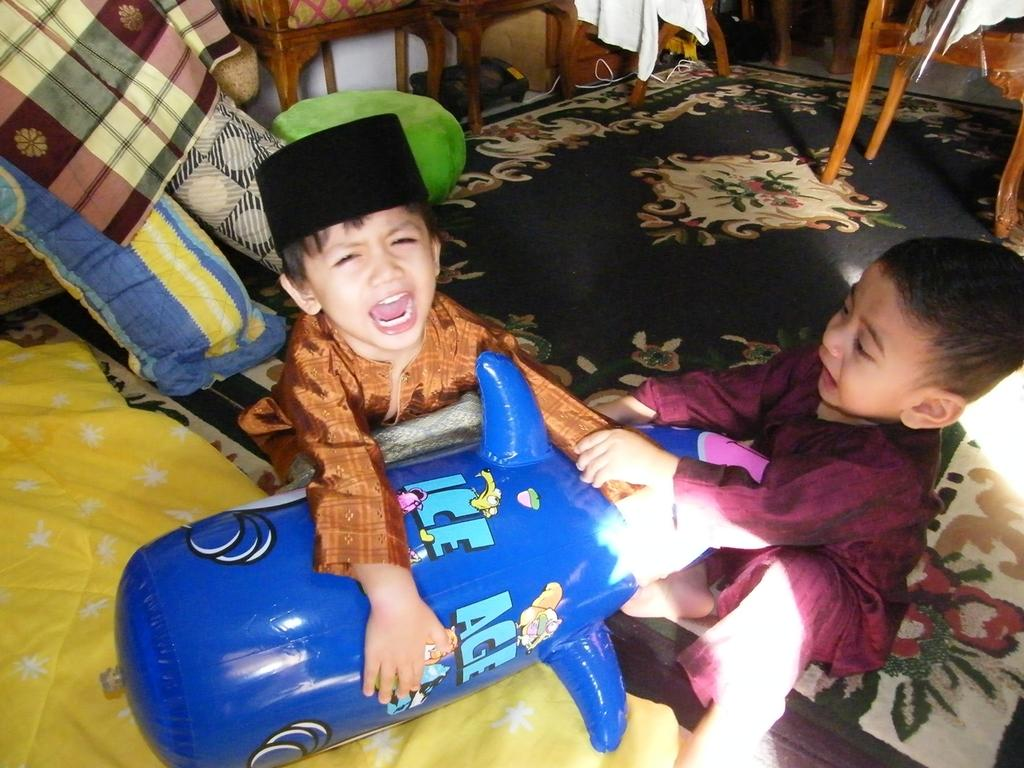How many children are in the image? There are two children in the image. What are the children doing in the image? The children are shouting for a toy. Can you describe any other toys visible in the image? Yes, there is another toy visible in the background. What other objects can be seen in the background of the image? There is a chair, a machine, cloth, and a mattress in the background. What type of porter is helping the children in the image? There is no porter present in the image to help the children. How does the beginner learn to use the machine in the image? There is no indication in the image that anyone is learning to use the machine, nor is there any information about the machine's function or purpose. 